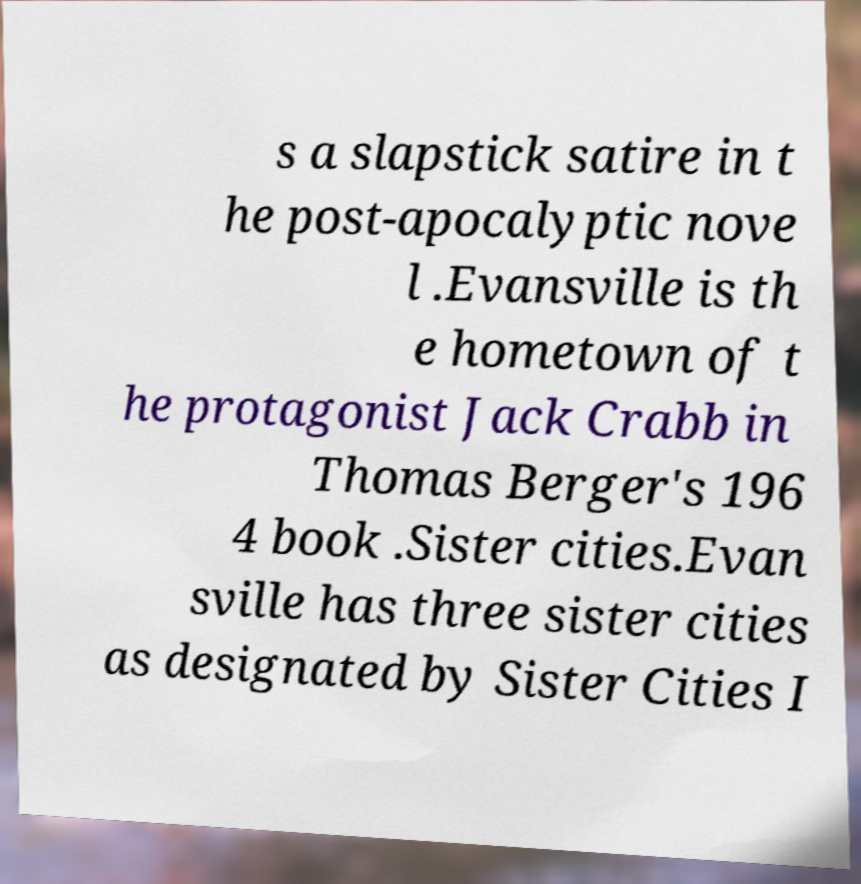Can you accurately transcribe the text from the provided image for me? s a slapstick satire in t he post-apocalyptic nove l .Evansville is th e hometown of t he protagonist Jack Crabb in Thomas Berger's 196 4 book .Sister cities.Evan sville has three sister cities as designated by Sister Cities I 